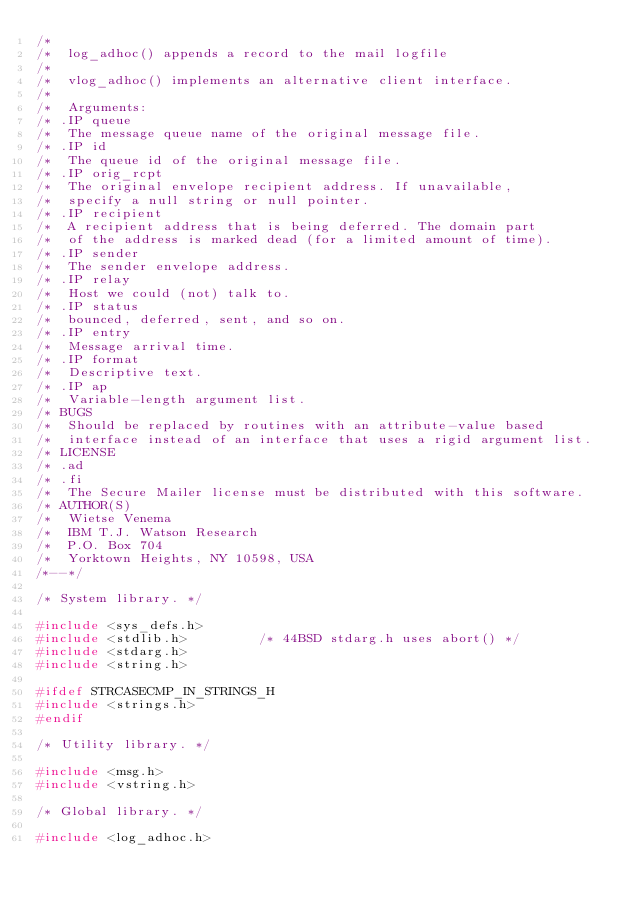Convert code to text. <code><loc_0><loc_0><loc_500><loc_500><_C_>/*
/*	log_adhoc() appends a record to the mail logfile
/*
/*	vlog_adhoc() implements an alternative client interface.
/*
/*	Arguments:
/* .IP queue
/*	The message queue name of the original message file.
/* .IP id
/*	The queue id of the original message file.
/* .IP orig_rcpt
/*	The original envelope recipient address. If unavailable,
/*	specify a null string or null pointer.
/* .IP recipient
/*	A recipient address that is being deferred. The domain part
/*	of the address is marked dead (for a limited amount of time).
/* .IP sender
/*	The sender envelope address.
/* .IP relay
/*	Host we could (not) talk to.
/* .IP status
/*	bounced, deferred, sent, and so on.
/* .IP entry
/*	Message arrival time.
/* .IP format
/*	Descriptive text.
/* .IP ap
/*	Variable-length argument list.
/* BUGS
/*	Should be replaced by routines with an attribute-value based
/*	interface instead of an interface that uses a rigid argument list.
/* LICENSE
/* .ad
/* .fi
/*	The Secure Mailer license must be distributed with this software.
/* AUTHOR(S)
/*	Wietse Venema
/*	IBM T.J. Watson Research
/*	P.O. Box 704
/*	Yorktown Heights, NY 10598, USA
/*--*/

/* System library. */

#include <sys_defs.h>
#include <stdlib.h>			/* 44BSD stdarg.h uses abort() */
#include <stdarg.h>
#include <string.h>

#ifdef STRCASECMP_IN_STRINGS_H
#include <strings.h>
#endif

/* Utility library. */

#include <msg.h>
#include <vstring.h>

/* Global library. */

#include <log_adhoc.h>
</code> 